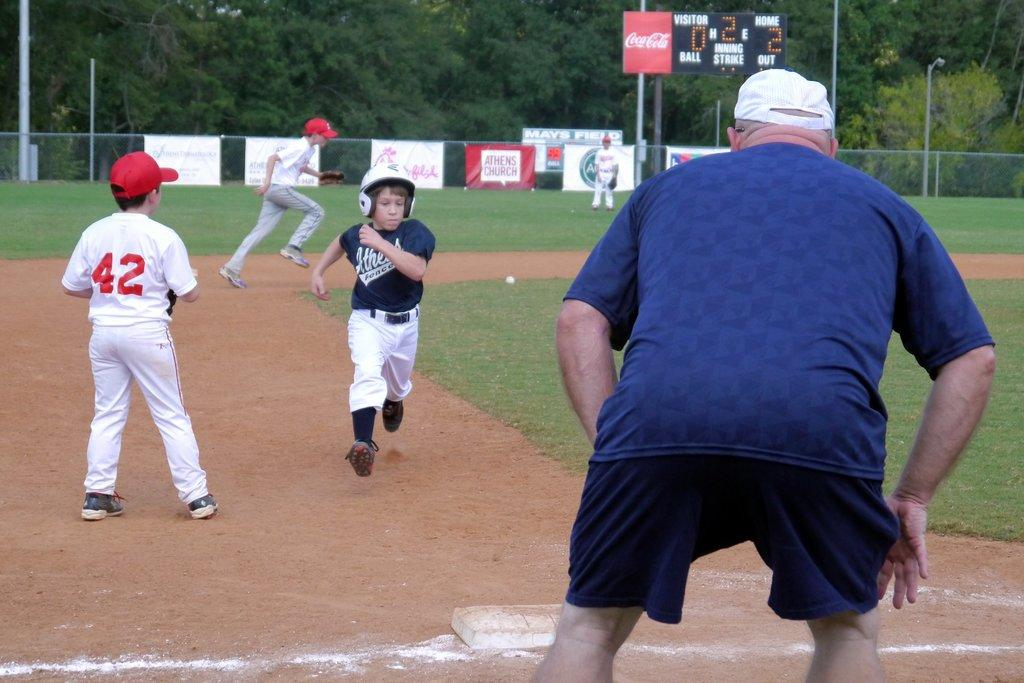<image>
Describe the image concisely. Athens Church has a red banner along the fence surrounding the field. 